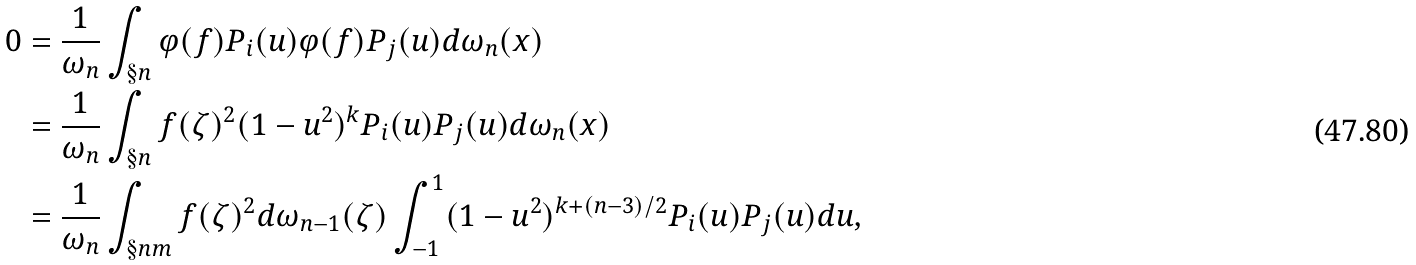Convert formula to latex. <formula><loc_0><loc_0><loc_500><loc_500>0 & = \frac { 1 } { \omega _ { n } } \int _ { \S n } \varphi ( f ) P _ { i } ( u ) \varphi ( f ) P _ { j } ( u ) d \omega _ { n } ( x ) \\ & = \frac { 1 } { \omega _ { n } } \int _ { \S n } f ( \zeta ) ^ { 2 } ( 1 - u ^ { 2 } ) ^ { k } P _ { i } ( u ) P _ { j } ( u ) d \omega _ { n } ( x ) \\ & = \frac { 1 } { \omega _ { n } } \int _ { \S n m } f ( \zeta ) ^ { 2 } d \omega _ { n - 1 } ( \zeta ) \int _ { - 1 } ^ { 1 } ( 1 - u ^ { 2 } ) ^ { k + ( n - 3 ) / 2 } P _ { i } ( u ) P _ { j } ( u ) d u ,</formula> 